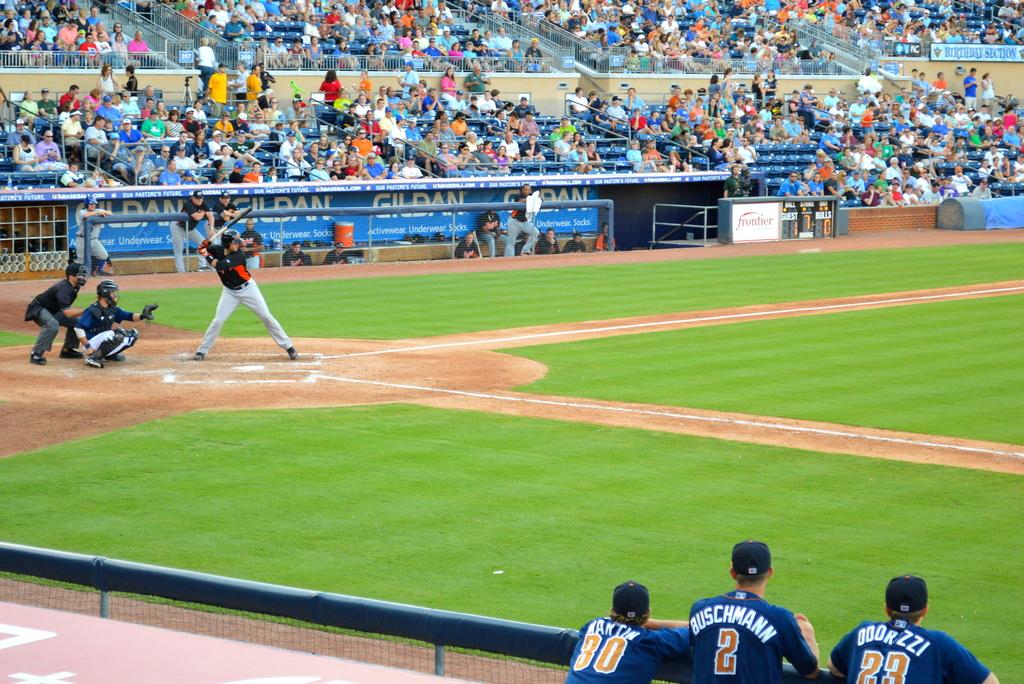Who is number #2 on the team?
Your answer should be very brief. Buschmann. What number is the player on the bottom right?
Offer a terse response. 23. 